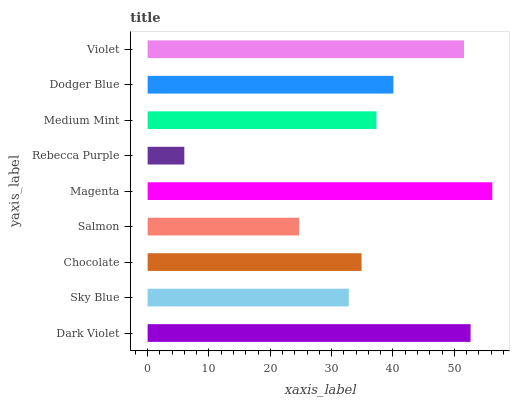Is Rebecca Purple the minimum?
Answer yes or no. Yes. Is Magenta the maximum?
Answer yes or no. Yes. Is Sky Blue the minimum?
Answer yes or no. No. Is Sky Blue the maximum?
Answer yes or no. No. Is Dark Violet greater than Sky Blue?
Answer yes or no. Yes. Is Sky Blue less than Dark Violet?
Answer yes or no. Yes. Is Sky Blue greater than Dark Violet?
Answer yes or no. No. Is Dark Violet less than Sky Blue?
Answer yes or no. No. Is Medium Mint the high median?
Answer yes or no. Yes. Is Medium Mint the low median?
Answer yes or no. Yes. Is Dodger Blue the high median?
Answer yes or no. No. Is Dark Violet the low median?
Answer yes or no. No. 